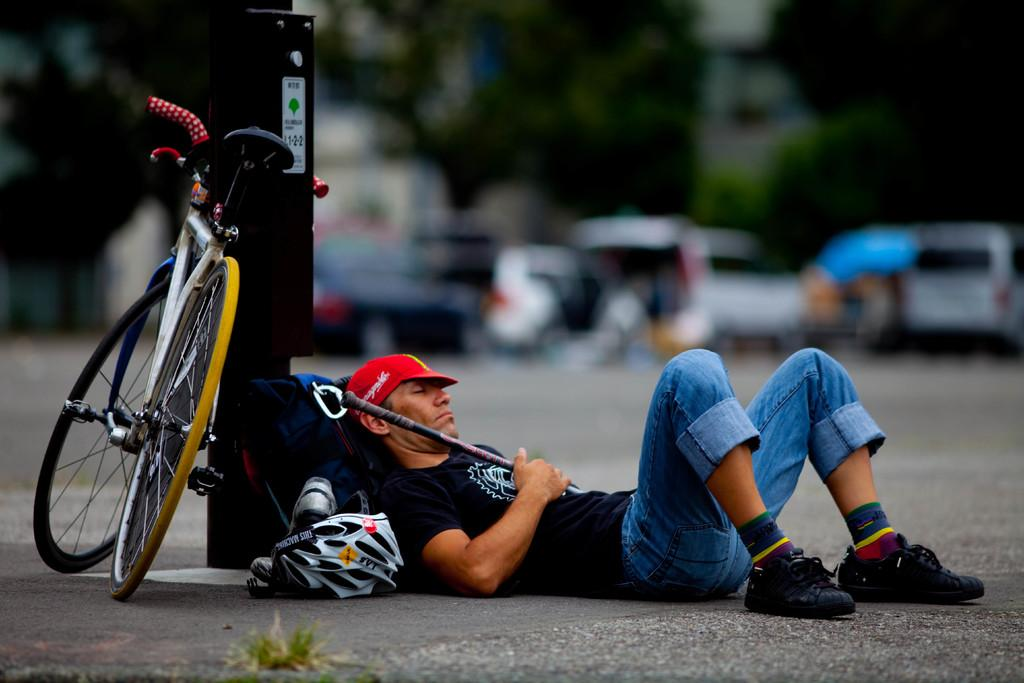What is the main object in the image? There is a bicycle in the image. What safety equipment is visible in the image? There is a helmet in the image. What is the condition of the man in the image? The man is lying on the road in the image. What can be seen in the distance in the image? Vehicles and trees are visible in the background of the image. How would you describe the background of the image? The background appears blurry. What type of paper is the man holding in the image? There is no paper visible in the image; the man is lying on the road. What statement does the bicycle make about the man's tendency to ride safely? The presence of the helmet suggests that the man may have a tendency to ride safely, but the image does not make a statement about the man's habits or tendencies. 